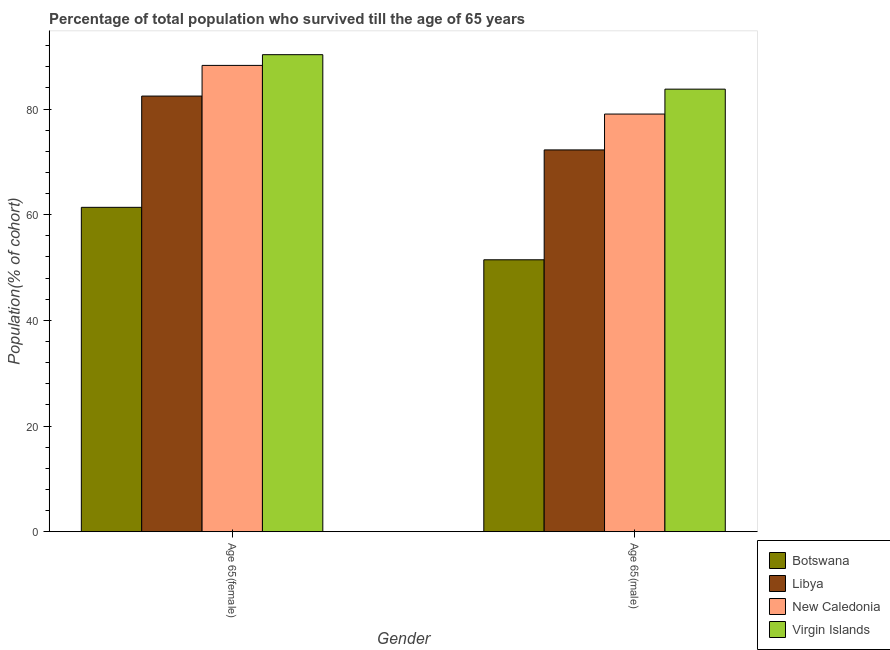How many bars are there on the 2nd tick from the right?
Provide a succinct answer. 4. What is the label of the 1st group of bars from the left?
Your answer should be very brief. Age 65(female). What is the percentage of male population who survived till age of 65 in Virgin Islands?
Keep it short and to the point. 83.76. Across all countries, what is the maximum percentage of female population who survived till age of 65?
Ensure brevity in your answer.  90.28. Across all countries, what is the minimum percentage of male population who survived till age of 65?
Make the answer very short. 51.47. In which country was the percentage of male population who survived till age of 65 maximum?
Make the answer very short. Virgin Islands. In which country was the percentage of female population who survived till age of 65 minimum?
Provide a succinct answer. Botswana. What is the total percentage of male population who survived till age of 65 in the graph?
Offer a terse response. 286.53. What is the difference between the percentage of female population who survived till age of 65 in Libya and that in Botswana?
Provide a succinct answer. 21.06. What is the difference between the percentage of female population who survived till age of 65 in Botswana and the percentage of male population who survived till age of 65 in New Caledonia?
Give a very brief answer. -17.65. What is the average percentage of female population who survived till age of 65 per country?
Keep it short and to the point. 80.59. What is the difference between the percentage of male population who survived till age of 65 and percentage of female population who survived till age of 65 in New Caledonia?
Offer a very short reply. -9.21. What is the ratio of the percentage of female population who survived till age of 65 in Virgin Islands to that in Botswana?
Give a very brief answer. 1.47. Is the percentage of male population who survived till age of 65 in New Caledonia less than that in Virgin Islands?
Offer a terse response. Yes. What does the 2nd bar from the left in Age 65(female) represents?
Provide a succinct answer. Libya. What does the 4th bar from the right in Age 65(male) represents?
Provide a short and direct response. Botswana. How many bars are there?
Give a very brief answer. 8. Are all the bars in the graph horizontal?
Provide a short and direct response. No. How many countries are there in the graph?
Give a very brief answer. 4. What is the difference between two consecutive major ticks on the Y-axis?
Ensure brevity in your answer.  20. Are the values on the major ticks of Y-axis written in scientific E-notation?
Offer a very short reply. No. Does the graph contain grids?
Your answer should be very brief. No. Where does the legend appear in the graph?
Your response must be concise. Bottom right. How many legend labels are there?
Ensure brevity in your answer.  4. What is the title of the graph?
Provide a short and direct response. Percentage of total population who survived till the age of 65 years. Does "Palau" appear as one of the legend labels in the graph?
Your answer should be compact. No. What is the label or title of the Y-axis?
Your answer should be very brief. Population(% of cohort). What is the Population(% of cohort) of Botswana in Age 65(female)?
Offer a very short reply. 61.39. What is the Population(% of cohort) in Libya in Age 65(female)?
Your response must be concise. 82.45. What is the Population(% of cohort) of New Caledonia in Age 65(female)?
Provide a succinct answer. 88.25. What is the Population(% of cohort) in Virgin Islands in Age 65(female)?
Your answer should be compact. 90.28. What is the Population(% of cohort) in Botswana in Age 65(male)?
Keep it short and to the point. 51.47. What is the Population(% of cohort) in Libya in Age 65(male)?
Make the answer very short. 72.26. What is the Population(% of cohort) in New Caledonia in Age 65(male)?
Offer a terse response. 79.05. What is the Population(% of cohort) in Virgin Islands in Age 65(male)?
Offer a very short reply. 83.76. Across all Gender, what is the maximum Population(% of cohort) in Botswana?
Keep it short and to the point. 61.39. Across all Gender, what is the maximum Population(% of cohort) in Libya?
Keep it short and to the point. 82.45. Across all Gender, what is the maximum Population(% of cohort) of New Caledonia?
Your response must be concise. 88.25. Across all Gender, what is the maximum Population(% of cohort) in Virgin Islands?
Ensure brevity in your answer.  90.28. Across all Gender, what is the minimum Population(% of cohort) of Botswana?
Offer a very short reply. 51.47. Across all Gender, what is the minimum Population(% of cohort) of Libya?
Offer a terse response. 72.26. Across all Gender, what is the minimum Population(% of cohort) in New Caledonia?
Offer a terse response. 79.05. Across all Gender, what is the minimum Population(% of cohort) in Virgin Islands?
Offer a terse response. 83.76. What is the total Population(% of cohort) of Botswana in the graph?
Offer a very short reply. 112.86. What is the total Population(% of cohort) in Libya in the graph?
Give a very brief answer. 154.71. What is the total Population(% of cohort) of New Caledonia in the graph?
Provide a succinct answer. 167.3. What is the total Population(% of cohort) of Virgin Islands in the graph?
Provide a succinct answer. 174.04. What is the difference between the Population(% of cohort) in Botswana in Age 65(female) and that in Age 65(male)?
Ensure brevity in your answer.  9.93. What is the difference between the Population(% of cohort) of Libya in Age 65(female) and that in Age 65(male)?
Keep it short and to the point. 10.19. What is the difference between the Population(% of cohort) of New Caledonia in Age 65(female) and that in Age 65(male)?
Your response must be concise. 9.21. What is the difference between the Population(% of cohort) in Virgin Islands in Age 65(female) and that in Age 65(male)?
Offer a very short reply. 6.52. What is the difference between the Population(% of cohort) in Botswana in Age 65(female) and the Population(% of cohort) in Libya in Age 65(male)?
Your answer should be very brief. -10.87. What is the difference between the Population(% of cohort) of Botswana in Age 65(female) and the Population(% of cohort) of New Caledonia in Age 65(male)?
Offer a very short reply. -17.65. What is the difference between the Population(% of cohort) in Botswana in Age 65(female) and the Population(% of cohort) in Virgin Islands in Age 65(male)?
Your response must be concise. -22.37. What is the difference between the Population(% of cohort) of Libya in Age 65(female) and the Population(% of cohort) of New Caledonia in Age 65(male)?
Give a very brief answer. 3.4. What is the difference between the Population(% of cohort) in Libya in Age 65(female) and the Population(% of cohort) in Virgin Islands in Age 65(male)?
Keep it short and to the point. -1.31. What is the difference between the Population(% of cohort) of New Caledonia in Age 65(female) and the Population(% of cohort) of Virgin Islands in Age 65(male)?
Your answer should be very brief. 4.49. What is the average Population(% of cohort) of Botswana per Gender?
Offer a terse response. 56.43. What is the average Population(% of cohort) of Libya per Gender?
Keep it short and to the point. 77.35. What is the average Population(% of cohort) of New Caledonia per Gender?
Give a very brief answer. 83.65. What is the average Population(% of cohort) of Virgin Islands per Gender?
Ensure brevity in your answer.  87.02. What is the difference between the Population(% of cohort) in Botswana and Population(% of cohort) in Libya in Age 65(female)?
Offer a terse response. -21.06. What is the difference between the Population(% of cohort) in Botswana and Population(% of cohort) in New Caledonia in Age 65(female)?
Your answer should be compact. -26.86. What is the difference between the Population(% of cohort) of Botswana and Population(% of cohort) of Virgin Islands in Age 65(female)?
Provide a succinct answer. -28.89. What is the difference between the Population(% of cohort) in Libya and Population(% of cohort) in New Caledonia in Age 65(female)?
Make the answer very short. -5.8. What is the difference between the Population(% of cohort) of Libya and Population(% of cohort) of Virgin Islands in Age 65(female)?
Keep it short and to the point. -7.83. What is the difference between the Population(% of cohort) in New Caledonia and Population(% of cohort) in Virgin Islands in Age 65(female)?
Ensure brevity in your answer.  -2.03. What is the difference between the Population(% of cohort) of Botswana and Population(% of cohort) of Libya in Age 65(male)?
Provide a succinct answer. -20.79. What is the difference between the Population(% of cohort) of Botswana and Population(% of cohort) of New Caledonia in Age 65(male)?
Ensure brevity in your answer.  -27.58. What is the difference between the Population(% of cohort) in Botswana and Population(% of cohort) in Virgin Islands in Age 65(male)?
Your answer should be compact. -32.29. What is the difference between the Population(% of cohort) in Libya and Population(% of cohort) in New Caledonia in Age 65(male)?
Ensure brevity in your answer.  -6.79. What is the difference between the Population(% of cohort) in Libya and Population(% of cohort) in Virgin Islands in Age 65(male)?
Your answer should be compact. -11.5. What is the difference between the Population(% of cohort) in New Caledonia and Population(% of cohort) in Virgin Islands in Age 65(male)?
Your response must be concise. -4.71. What is the ratio of the Population(% of cohort) of Botswana in Age 65(female) to that in Age 65(male)?
Offer a very short reply. 1.19. What is the ratio of the Population(% of cohort) in Libya in Age 65(female) to that in Age 65(male)?
Make the answer very short. 1.14. What is the ratio of the Population(% of cohort) of New Caledonia in Age 65(female) to that in Age 65(male)?
Your answer should be compact. 1.12. What is the ratio of the Population(% of cohort) in Virgin Islands in Age 65(female) to that in Age 65(male)?
Offer a terse response. 1.08. What is the difference between the highest and the second highest Population(% of cohort) of Botswana?
Provide a short and direct response. 9.93. What is the difference between the highest and the second highest Population(% of cohort) of Libya?
Offer a terse response. 10.19. What is the difference between the highest and the second highest Population(% of cohort) in New Caledonia?
Keep it short and to the point. 9.21. What is the difference between the highest and the second highest Population(% of cohort) in Virgin Islands?
Provide a succinct answer. 6.52. What is the difference between the highest and the lowest Population(% of cohort) of Botswana?
Your answer should be very brief. 9.93. What is the difference between the highest and the lowest Population(% of cohort) in Libya?
Ensure brevity in your answer.  10.19. What is the difference between the highest and the lowest Population(% of cohort) in New Caledonia?
Your response must be concise. 9.21. What is the difference between the highest and the lowest Population(% of cohort) of Virgin Islands?
Offer a very short reply. 6.52. 